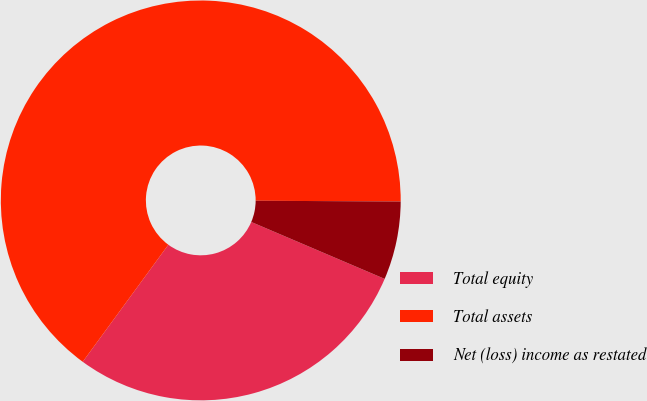<chart> <loc_0><loc_0><loc_500><loc_500><pie_chart><fcel>Total equity<fcel>Total assets<fcel>Net (loss) income as restated<nl><fcel>28.63%<fcel>65.03%<fcel>6.33%<nl></chart> 